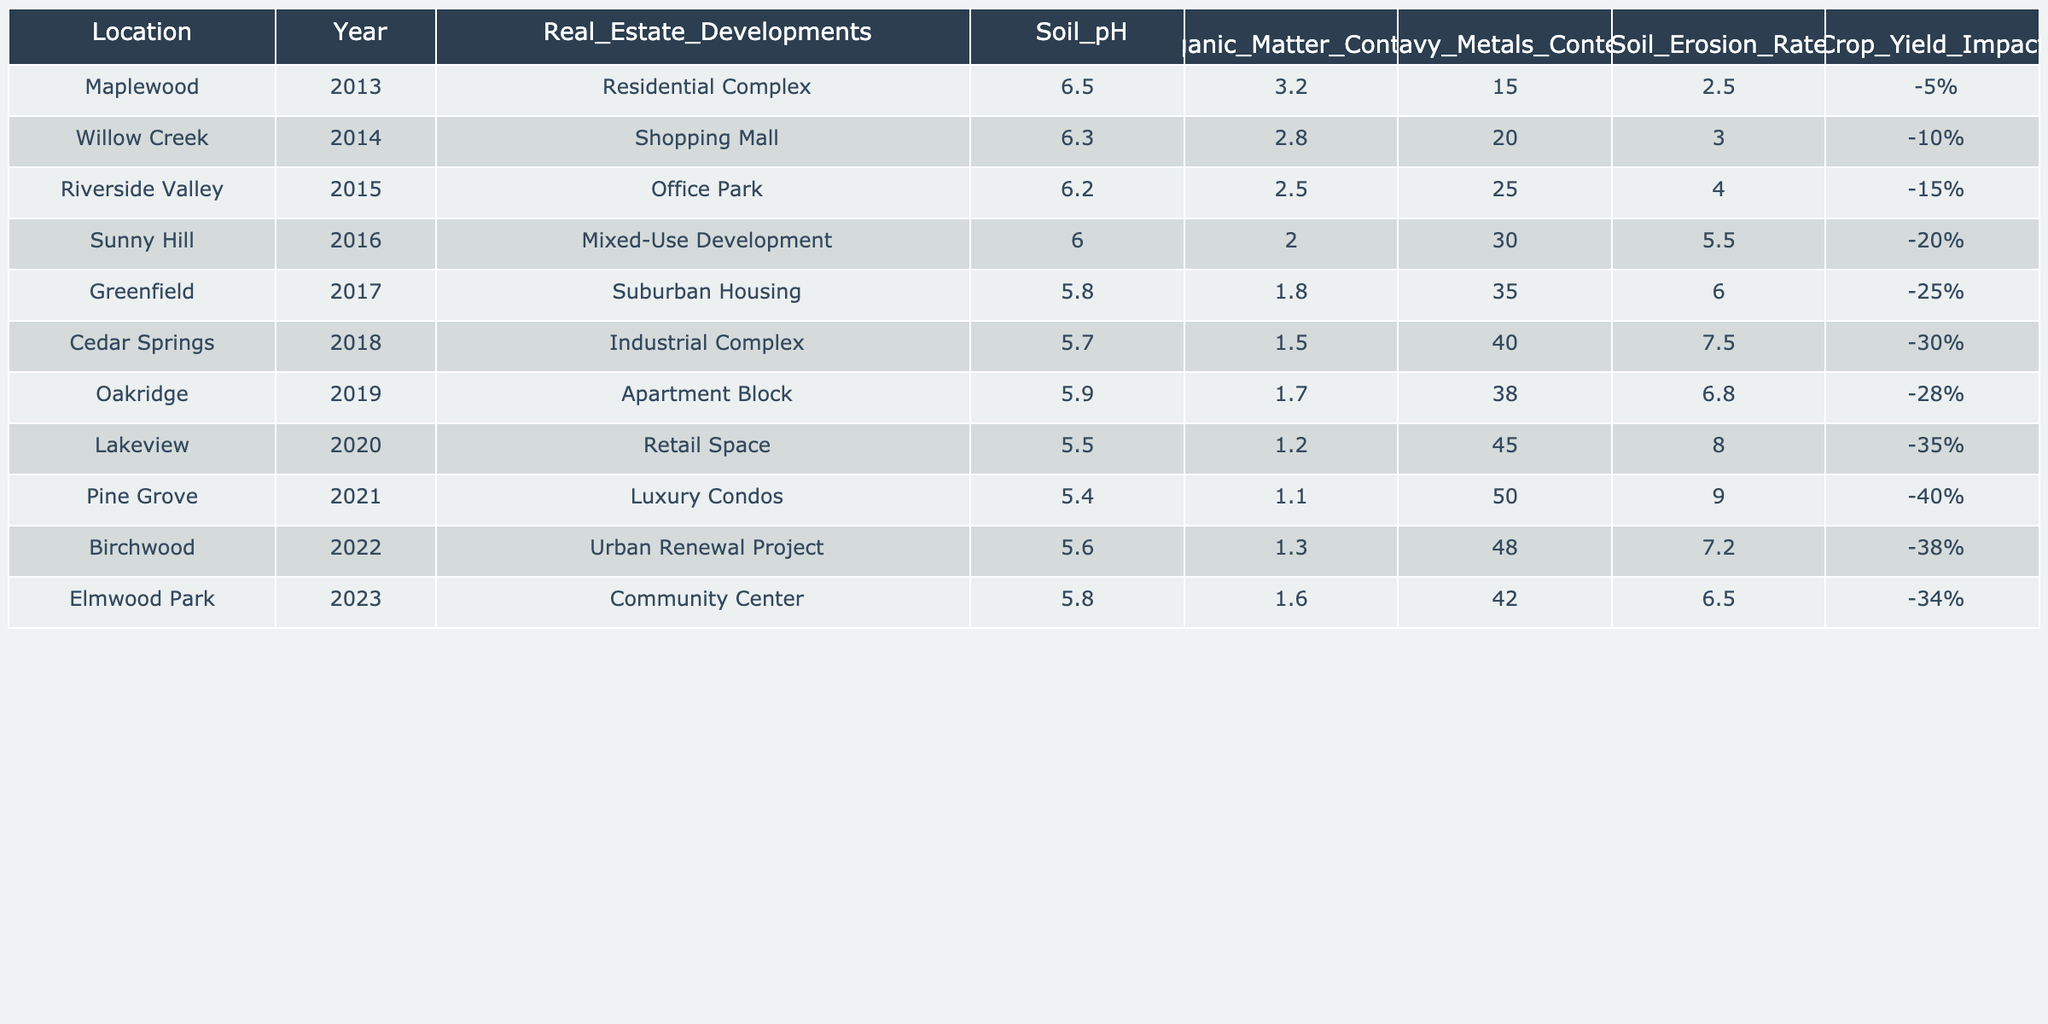What was the soil pH in Greenfield in 2017? Referring to the table, the data for Greenfield in 2017 shows that the soil pH was 5.8.
Answer: 5.8 How many real estate developments occurred in the past decade? Counting the entries in the table, there are 10 distinct real estate developments listed from 2013 to 2023.
Answer: 10 What is the trend in organic matter content from 2013 to 2023? The organic matter content decreased from 3.2 in 2013 to 1.6 in 2023, indicating a downward trend over the decade.
Answer: Decreasing What is the difference in heavy metals content between Sunny Hill (2016) and Lakeview (2020)? The heavy metals content in Sunny Hill was 30, while in Lakeview it was 45. The difference is 45 - 30 = 15.
Answer: 15 Which location had the highest soil erosion rate, and what was the rate? Looking at the table, Pine Grove (2021) had the highest soil erosion rate of 9.0, making it the highest among all entries.
Answer: Pine Grove, 9.0 What was the average crop yield impact across the locations from 2013 to 2023? The crop yield impacts from each location are -5%, -10%, -15%, -20%, -25%, -30%, -28%, -35%, -40%, -38%, and -34%. Summing these gives a total of -315%. Dividing this by 10 provides an average of -31.5%.
Answer: -31.5% Is there a consistent decline in soil pH over the years, and what was the soil pH in the last entry? By examining the table, soil pH consistently declined from 6.5 in 2013 to 5.8 in 2023. In the last entry for Elmwood Park (2023), the soil pH was noted as 5.8.
Answer: Yes, 5.8 What was the crop yield impact in Riverside Valley in 2015 compared to Greenfield in 2017? Riverside Valley in 2015 had a crop yield impact of -15%, while Greenfield in 2017 had an impact of -25%. Therefore, Riverside Valley had a smaller negative impact.
Answer: Riverside Valley, -15% Which year saw the least organic matter content and what was the content level? Examining the table, Cedar Springs in 2018 had the least organic matter content at 1.5.
Answer: 1.5 How did the soil pH change from 2013 to 2022? In 2013, the soil pH was 6.5 and in 2022 it was 5.6. The change shows a decrease of 0.9 over the 10 years.
Answer: Decreased by 0.9 